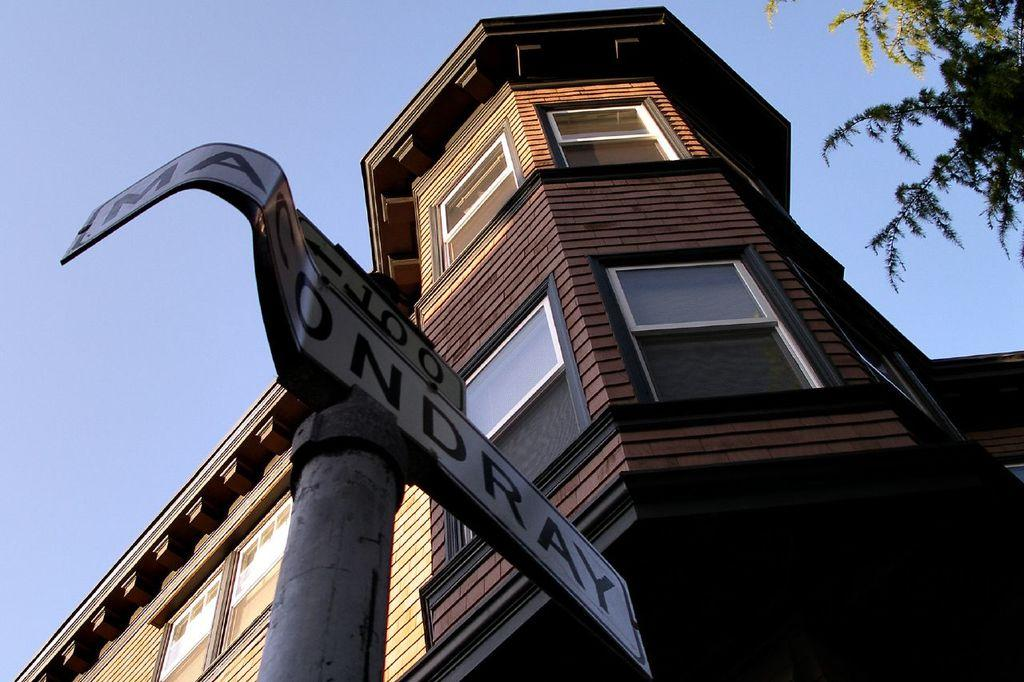What is located at the front of the image? There is a pole with text in the front of the image. What structure is in the center of the image? There is a building in the center of the image. What type of vegetation is on the right side of the image? There are leaves on the right side of the image. What color is the scarf that the sun is wearing in the image? There is no scarf or sun present in the image. What type of range can be seen in the background of the image? There is no range visible in the image; it features a pole with text, a building, and leaves. 